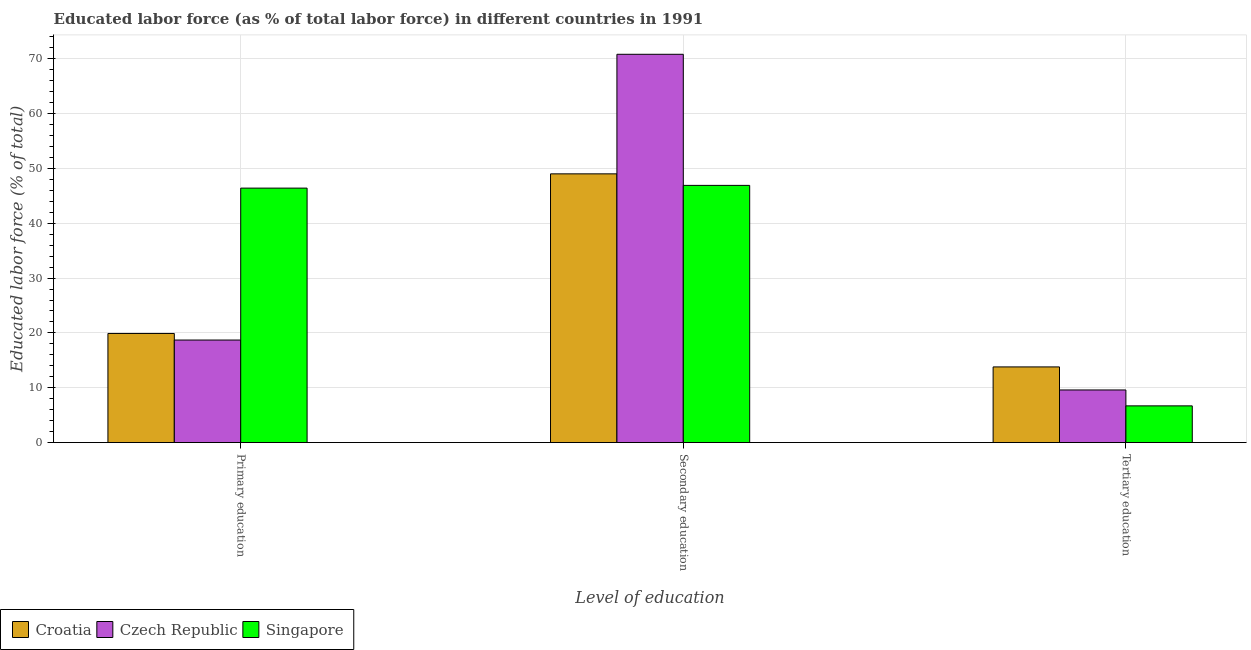How many different coloured bars are there?
Keep it short and to the point. 3. How many bars are there on the 3rd tick from the left?
Provide a short and direct response. 3. How many bars are there on the 1st tick from the right?
Your response must be concise. 3. What is the percentage of labor force who received tertiary education in Singapore?
Offer a very short reply. 6.7. Across all countries, what is the maximum percentage of labor force who received tertiary education?
Make the answer very short. 13.8. Across all countries, what is the minimum percentage of labor force who received tertiary education?
Provide a short and direct response. 6.7. In which country was the percentage of labor force who received primary education maximum?
Your response must be concise. Singapore. In which country was the percentage of labor force who received tertiary education minimum?
Your answer should be very brief. Singapore. What is the total percentage of labor force who received tertiary education in the graph?
Your answer should be very brief. 30.1. What is the difference between the percentage of labor force who received tertiary education in Czech Republic and that in Singapore?
Your response must be concise. 2.9. What is the difference between the percentage of labor force who received tertiary education in Czech Republic and the percentage of labor force who received primary education in Croatia?
Your answer should be very brief. -10.3. What is the average percentage of labor force who received primary education per country?
Your response must be concise. 28.33. What is the difference between the percentage of labor force who received secondary education and percentage of labor force who received tertiary education in Croatia?
Your answer should be very brief. 35.2. In how many countries, is the percentage of labor force who received tertiary education greater than 44 %?
Ensure brevity in your answer.  0. What is the ratio of the percentage of labor force who received primary education in Singapore to that in Czech Republic?
Your answer should be compact. 2.48. Is the difference between the percentage of labor force who received primary education in Singapore and Czech Republic greater than the difference between the percentage of labor force who received secondary education in Singapore and Czech Republic?
Ensure brevity in your answer.  Yes. What is the difference between the highest and the second highest percentage of labor force who received secondary education?
Provide a short and direct response. 21.8. What is the difference between the highest and the lowest percentage of labor force who received tertiary education?
Your response must be concise. 7.1. Is the sum of the percentage of labor force who received primary education in Czech Republic and Croatia greater than the maximum percentage of labor force who received secondary education across all countries?
Your answer should be very brief. No. What does the 3rd bar from the left in Tertiary education represents?
Keep it short and to the point. Singapore. What does the 2nd bar from the right in Tertiary education represents?
Offer a terse response. Czech Republic. What is the title of the graph?
Your answer should be compact. Educated labor force (as % of total labor force) in different countries in 1991. What is the label or title of the X-axis?
Offer a very short reply. Level of education. What is the label or title of the Y-axis?
Offer a terse response. Educated labor force (% of total). What is the Educated labor force (% of total) of Croatia in Primary education?
Keep it short and to the point. 19.9. What is the Educated labor force (% of total) in Czech Republic in Primary education?
Your answer should be very brief. 18.7. What is the Educated labor force (% of total) of Singapore in Primary education?
Keep it short and to the point. 46.4. What is the Educated labor force (% of total) of Croatia in Secondary education?
Your response must be concise. 49. What is the Educated labor force (% of total) in Czech Republic in Secondary education?
Make the answer very short. 70.8. What is the Educated labor force (% of total) of Singapore in Secondary education?
Provide a short and direct response. 46.9. What is the Educated labor force (% of total) of Croatia in Tertiary education?
Ensure brevity in your answer.  13.8. What is the Educated labor force (% of total) in Czech Republic in Tertiary education?
Ensure brevity in your answer.  9.6. What is the Educated labor force (% of total) of Singapore in Tertiary education?
Keep it short and to the point. 6.7. Across all Level of education, what is the maximum Educated labor force (% of total) of Czech Republic?
Keep it short and to the point. 70.8. Across all Level of education, what is the maximum Educated labor force (% of total) in Singapore?
Your answer should be compact. 46.9. Across all Level of education, what is the minimum Educated labor force (% of total) in Croatia?
Offer a very short reply. 13.8. Across all Level of education, what is the minimum Educated labor force (% of total) of Czech Republic?
Ensure brevity in your answer.  9.6. Across all Level of education, what is the minimum Educated labor force (% of total) of Singapore?
Your answer should be very brief. 6.7. What is the total Educated labor force (% of total) of Croatia in the graph?
Provide a succinct answer. 82.7. What is the total Educated labor force (% of total) in Czech Republic in the graph?
Provide a succinct answer. 99.1. What is the difference between the Educated labor force (% of total) in Croatia in Primary education and that in Secondary education?
Offer a very short reply. -29.1. What is the difference between the Educated labor force (% of total) in Czech Republic in Primary education and that in Secondary education?
Your answer should be very brief. -52.1. What is the difference between the Educated labor force (% of total) in Czech Republic in Primary education and that in Tertiary education?
Your answer should be compact. 9.1. What is the difference between the Educated labor force (% of total) in Singapore in Primary education and that in Tertiary education?
Make the answer very short. 39.7. What is the difference between the Educated labor force (% of total) in Croatia in Secondary education and that in Tertiary education?
Make the answer very short. 35.2. What is the difference between the Educated labor force (% of total) of Czech Republic in Secondary education and that in Tertiary education?
Make the answer very short. 61.2. What is the difference between the Educated labor force (% of total) in Singapore in Secondary education and that in Tertiary education?
Your answer should be very brief. 40.2. What is the difference between the Educated labor force (% of total) in Croatia in Primary education and the Educated labor force (% of total) in Czech Republic in Secondary education?
Provide a succinct answer. -50.9. What is the difference between the Educated labor force (% of total) of Croatia in Primary education and the Educated labor force (% of total) of Singapore in Secondary education?
Your answer should be very brief. -27. What is the difference between the Educated labor force (% of total) in Czech Republic in Primary education and the Educated labor force (% of total) in Singapore in Secondary education?
Your response must be concise. -28.2. What is the difference between the Educated labor force (% of total) of Croatia in Primary education and the Educated labor force (% of total) of Czech Republic in Tertiary education?
Keep it short and to the point. 10.3. What is the difference between the Educated labor force (% of total) of Czech Republic in Primary education and the Educated labor force (% of total) of Singapore in Tertiary education?
Your answer should be compact. 12. What is the difference between the Educated labor force (% of total) of Croatia in Secondary education and the Educated labor force (% of total) of Czech Republic in Tertiary education?
Offer a very short reply. 39.4. What is the difference between the Educated labor force (% of total) of Croatia in Secondary education and the Educated labor force (% of total) of Singapore in Tertiary education?
Keep it short and to the point. 42.3. What is the difference between the Educated labor force (% of total) of Czech Republic in Secondary education and the Educated labor force (% of total) of Singapore in Tertiary education?
Your answer should be very brief. 64.1. What is the average Educated labor force (% of total) in Croatia per Level of education?
Give a very brief answer. 27.57. What is the average Educated labor force (% of total) in Czech Republic per Level of education?
Offer a very short reply. 33.03. What is the average Educated labor force (% of total) of Singapore per Level of education?
Give a very brief answer. 33.33. What is the difference between the Educated labor force (% of total) in Croatia and Educated labor force (% of total) in Czech Republic in Primary education?
Give a very brief answer. 1.2. What is the difference between the Educated labor force (% of total) in Croatia and Educated labor force (% of total) in Singapore in Primary education?
Give a very brief answer. -26.5. What is the difference between the Educated labor force (% of total) of Czech Republic and Educated labor force (% of total) of Singapore in Primary education?
Provide a succinct answer. -27.7. What is the difference between the Educated labor force (% of total) in Croatia and Educated labor force (% of total) in Czech Republic in Secondary education?
Keep it short and to the point. -21.8. What is the difference between the Educated labor force (% of total) of Croatia and Educated labor force (% of total) of Singapore in Secondary education?
Your response must be concise. 2.1. What is the difference between the Educated labor force (% of total) in Czech Republic and Educated labor force (% of total) in Singapore in Secondary education?
Ensure brevity in your answer.  23.9. What is the difference between the Educated labor force (% of total) of Croatia and Educated labor force (% of total) of Czech Republic in Tertiary education?
Your response must be concise. 4.2. What is the difference between the Educated labor force (% of total) in Croatia and Educated labor force (% of total) in Singapore in Tertiary education?
Give a very brief answer. 7.1. What is the difference between the Educated labor force (% of total) in Czech Republic and Educated labor force (% of total) in Singapore in Tertiary education?
Your answer should be very brief. 2.9. What is the ratio of the Educated labor force (% of total) in Croatia in Primary education to that in Secondary education?
Your answer should be compact. 0.41. What is the ratio of the Educated labor force (% of total) in Czech Republic in Primary education to that in Secondary education?
Offer a very short reply. 0.26. What is the ratio of the Educated labor force (% of total) of Singapore in Primary education to that in Secondary education?
Ensure brevity in your answer.  0.99. What is the ratio of the Educated labor force (% of total) of Croatia in Primary education to that in Tertiary education?
Your answer should be compact. 1.44. What is the ratio of the Educated labor force (% of total) in Czech Republic in Primary education to that in Tertiary education?
Make the answer very short. 1.95. What is the ratio of the Educated labor force (% of total) in Singapore in Primary education to that in Tertiary education?
Provide a short and direct response. 6.93. What is the ratio of the Educated labor force (% of total) of Croatia in Secondary education to that in Tertiary education?
Provide a succinct answer. 3.55. What is the ratio of the Educated labor force (% of total) in Czech Republic in Secondary education to that in Tertiary education?
Provide a short and direct response. 7.38. What is the difference between the highest and the second highest Educated labor force (% of total) of Croatia?
Your answer should be compact. 29.1. What is the difference between the highest and the second highest Educated labor force (% of total) of Czech Republic?
Provide a short and direct response. 52.1. What is the difference between the highest and the second highest Educated labor force (% of total) of Singapore?
Ensure brevity in your answer.  0.5. What is the difference between the highest and the lowest Educated labor force (% of total) of Croatia?
Make the answer very short. 35.2. What is the difference between the highest and the lowest Educated labor force (% of total) in Czech Republic?
Offer a very short reply. 61.2. What is the difference between the highest and the lowest Educated labor force (% of total) in Singapore?
Your response must be concise. 40.2. 